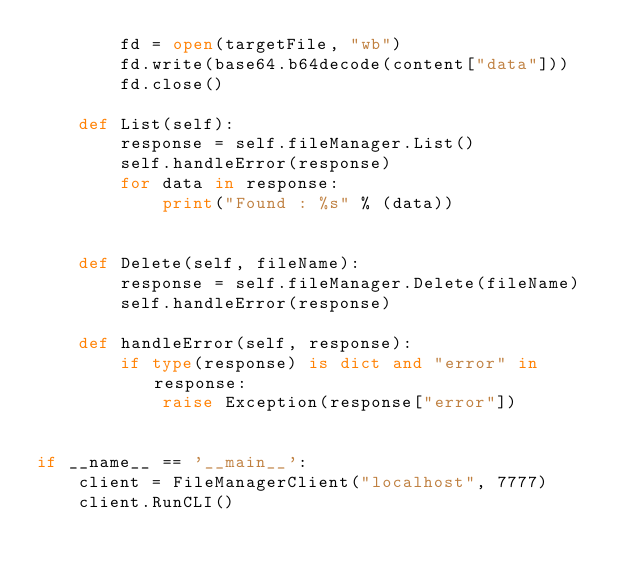<code> <loc_0><loc_0><loc_500><loc_500><_Python_>        fd = open(targetFile, "wb")
        fd.write(base64.b64decode(content["data"]))
        fd.close()

    def List(self):
        response = self.fileManager.List()
        self.handleError(response)
        for data in response:
            print("Found : %s" % (data))
    
        
    def Delete(self, fileName):
        response = self.fileManager.Delete(fileName)
        self.handleError(response)
    
    def handleError(self, response):
        if type(response) is dict and "error" in response:
            raise Exception(response["error"])


if __name__ == '__main__':
    client = FileManagerClient("localhost", 7777)
    client.RunCLI()</code> 